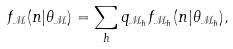<formula> <loc_0><loc_0><loc_500><loc_500>f _ { \mathcal { M } } ( n | \theta _ { \mathcal { M } } ) = \sum _ { h } q _ { { \mathcal { M } } _ { h } } f _ { { \mathcal { M } } _ { h } } ( n | \theta _ { { \mathcal { M } } _ { h } } ) ,</formula> 